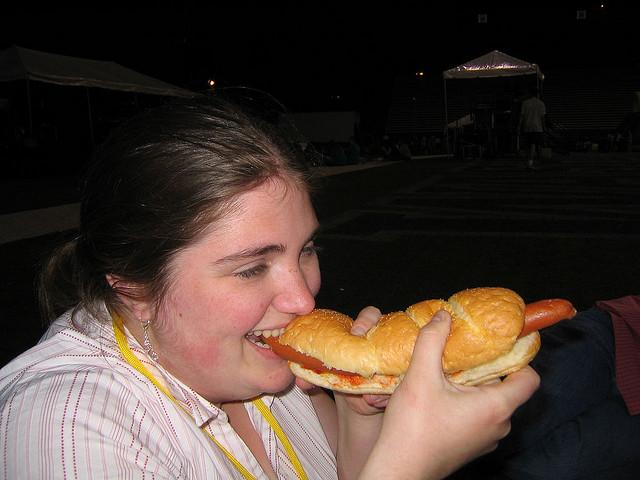What is she eating?
Quick response, please. Hot dog. Is there bread in her first bite?
Concise answer only. No. What is longer, the roll or the hot dog?
Quick response, please. Hot dog. What is the woman eating?
Short answer required. Hot dog. 